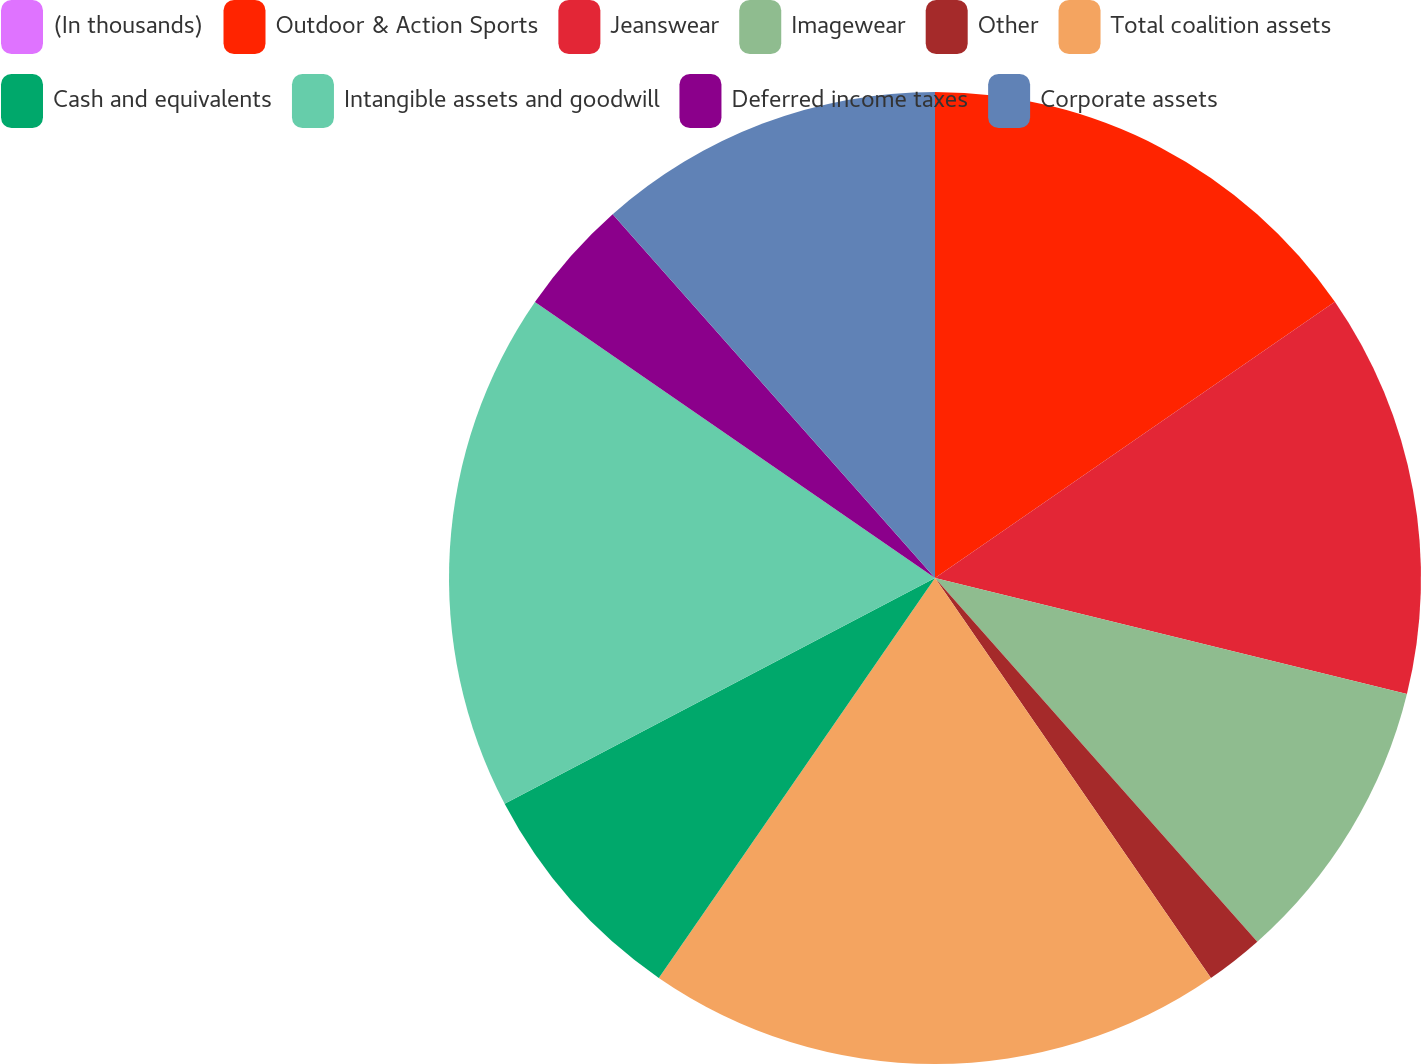Convert chart to OTSL. <chart><loc_0><loc_0><loc_500><loc_500><pie_chart><fcel>(In thousands)<fcel>Outdoor & Action Sports<fcel>Jeanswear<fcel>Imagewear<fcel>Other<fcel>Total coalition assets<fcel>Cash and equivalents<fcel>Intangible assets and goodwill<fcel>Deferred income taxes<fcel>Corporate assets<nl><fcel>0.0%<fcel>15.38%<fcel>13.46%<fcel>9.62%<fcel>1.93%<fcel>19.23%<fcel>7.69%<fcel>17.3%<fcel>3.85%<fcel>11.54%<nl></chart> 